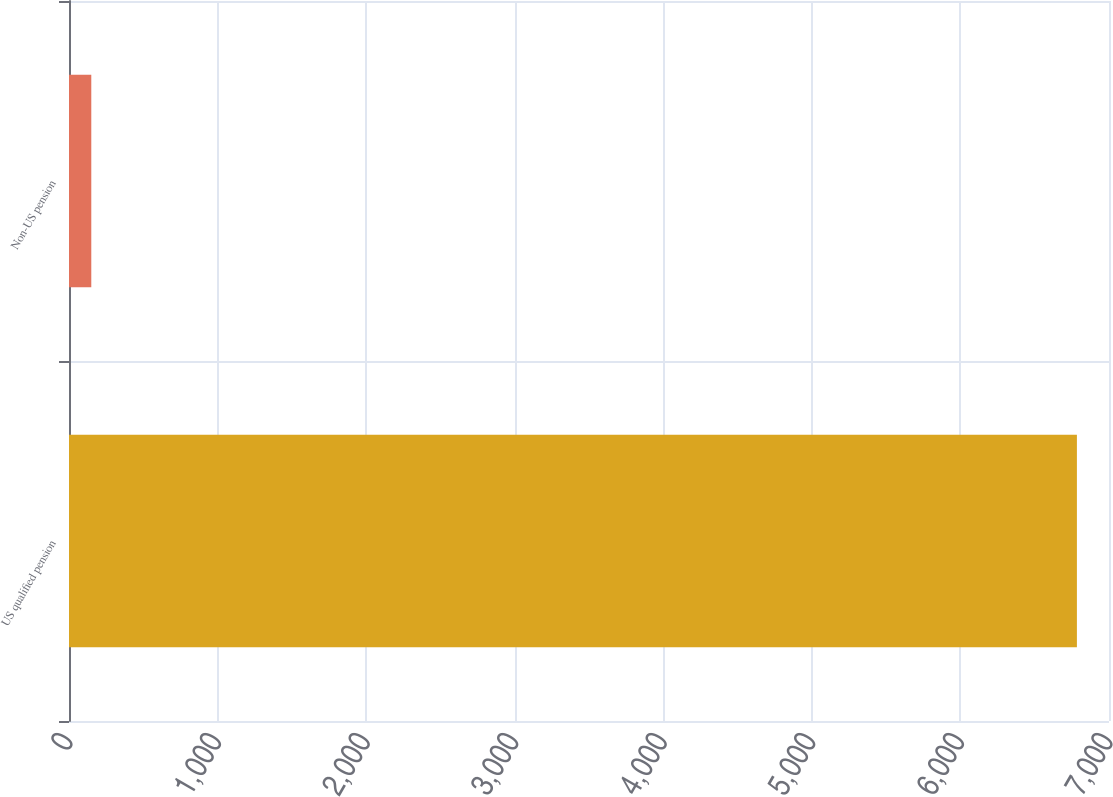Convert chart. <chart><loc_0><loc_0><loc_500><loc_500><bar_chart><fcel>US qualified pension<fcel>Non-US pension<nl><fcel>6784<fcel>150<nl></chart> 